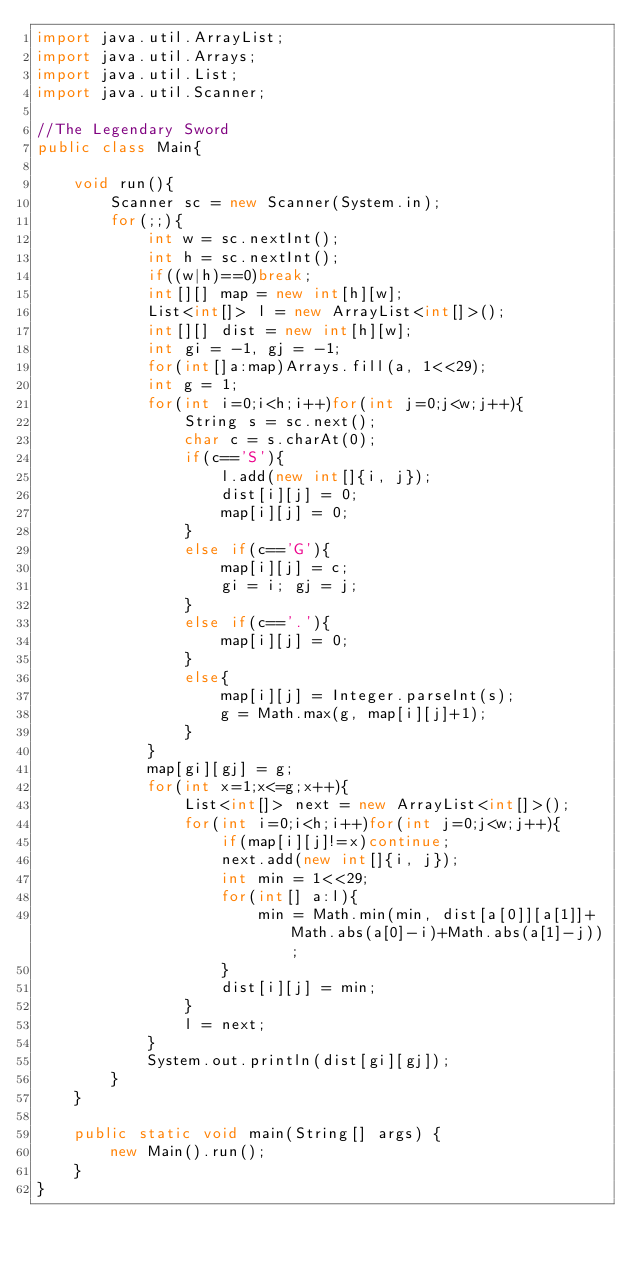Convert code to text. <code><loc_0><loc_0><loc_500><loc_500><_Java_>import java.util.ArrayList;
import java.util.Arrays;
import java.util.List;
import java.util.Scanner;

//The Legendary Sword
public class Main{

	void run(){
		Scanner sc = new Scanner(System.in);
		for(;;){
			int w = sc.nextInt();
			int h = sc.nextInt();
			if((w|h)==0)break;
			int[][] map = new int[h][w];
			List<int[]> l = new ArrayList<int[]>();
			int[][] dist = new int[h][w];
			int gi = -1, gj = -1;
			for(int[]a:map)Arrays.fill(a, 1<<29);
			int g = 1;
			for(int i=0;i<h;i++)for(int j=0;j<w;j++){
				String s = sc.next();
				char c = s.charAt(0);
				if(c=='S'){
					l.add(new int[]{i, j});
					dist[i][j] = 0;
					map[i][j] = 0;
				}
				else if(c=='G'){
					map[i][j] = c;
					gi = i; gj = j;
				}
				else if(c=='.'){
					map[i][j] = 0;
				}
				else{
					map[i][j] = Integer.parseInt(s);
					g = Math.max(g, map[i][j]+1);
				}
			}
			map[gi][gj] = g;
			for(int x=1;x<=g;x++){
				List<int[]> next = new ArrayList<int[]>();
				for(int i=0;i<h;i++)for(int j=0;j<w;j++){
					if(map[i][j]!=x)continue;
					next.add(new int[]{i, j});
					int min = 1<<29;
					for(int[] a:l){
						min = Math.min(min, dist[a[0]][a[1]]+Math.abs(a[0]-i)+Math.abs(a[1]-j));
					}
					dist[i][j] = min;
				}
				l = next;
			}
			System.out.println(dist[gi][gj]);
		}
	}
	
	public static void main(String[] args) {
		new Main().run();
	}
}</code> 